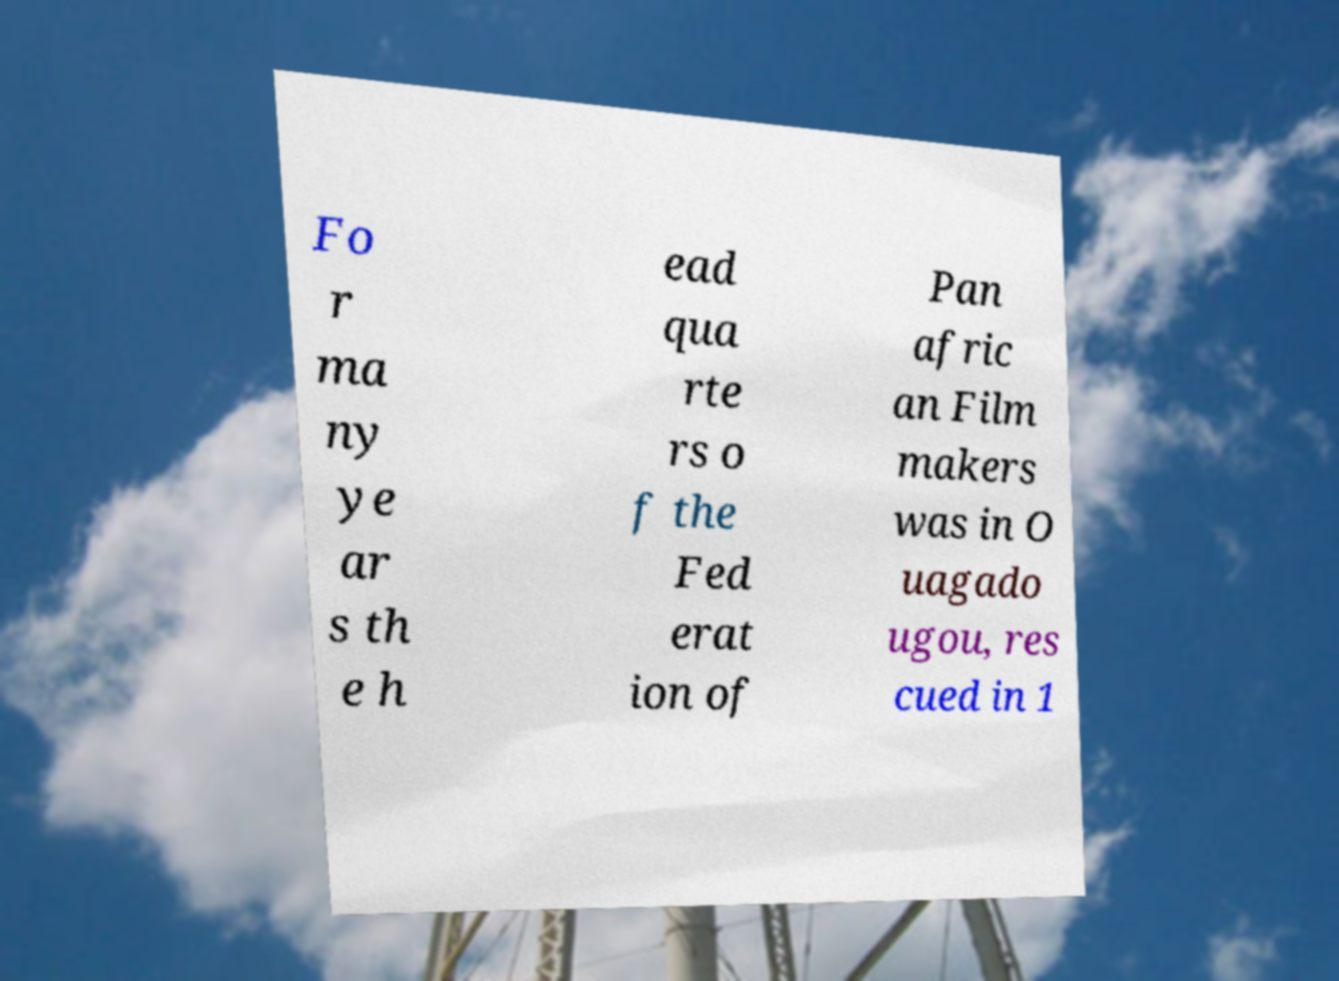Can you read and provide the text displayed in the image?This photo seems to have some interesting text. Can you extract and type it out for me? Fo r ma ny ye ar s th e h ead qua rte rs o f the Fed erat ion of Pan afric an Film makers was in O uagado ugou, res cued in 1 